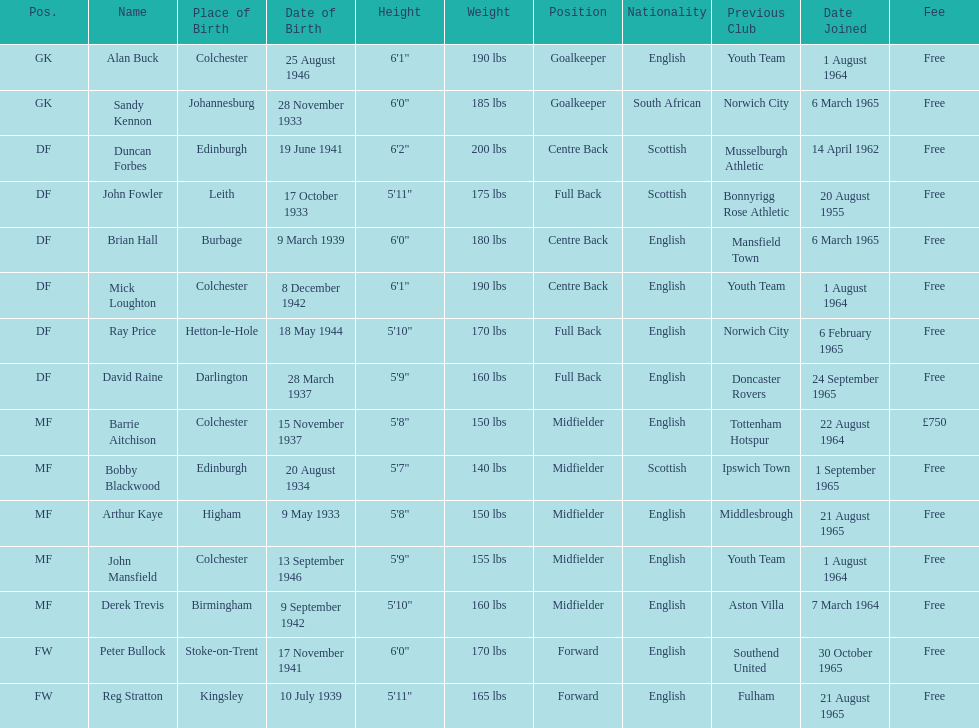I'm looking to parse the entire table for insights. Could you assist me with that? {'header': ['Pos.', 'Name', 'Place of Birth', 'Date of Birth', 'Height', 'Weight', 'Position', 'Nationality', 'Previous Club', 'Date Joined', 'Fee'], 'rows': [['GK', 'Alan Buck', 'Colchester', '25 August 1946', '6\'1"', '190 lbs', 'Goalkeeper', 'English', 'Youth Team', '1 August 1964', 'Free'], ['GK', 'Sandy Kennon', 'Johannesburg', '28 November 1933', '6\'0"', '185 lbs', 'Goalkeeper', 'South African', 'Norwich City', '6 March 1965', 'Free'], ['DF', 'Duncan Forbes', 'Edinburgh', '19 June 1941', '6\'2"', '200 lbs', 'Centre Back', 'Scottish', 'Musselburgh Athletic', '14 April 1962', 'Free'], ['DF', 'John Fowler', 'Leith', '17 October 1933', '5\'11"', '175 lbs', 'Full Back', 'Scottish', 'Bonnyrigg Rose Athletic', '20 August 1955', 'Free'], ['DF', 'Brian Hall', 'Burbage', '9 March 1939', '6\'0"', '180 lbs', 'Centre Back', 'English', 'Mansfield Town', '6 March 1965', 'Free'], ['DF', 'Mick Loughton', 'Colchester', '8 December 1942', '6\'1"', '190 lbs', 'Centre Back', 'English', 'Youth Team', '1 August 1964', 'Free'], ['DF', 'Ray Price', 'Hetton-le-Hole', '18 May 1944', '5\'10"', '170 lbs', 'Full Back', 'English', 'Norwich City', '6 February 1965', 'Free'], ['DF', 'David Raine', 'Darlington', '28 March 1937', '5\'9"', '160 lbs', 'Full Back', 'English', 'Doncaster Rovers', '24 September 1965', 'Free'], ['MF', 'Barrie Aitchison', 'Colchester', '15 November 1937', '5\'8"', '150 lbs', 'Midfielder', 'English', 'Tottenham Hotspur', '22 August 1964', '£750'], ['MF', 'Bobby Blackwood', 'Edinburgh', '20 August 1934', '5\'7"', '140 lbs', 'Midfielder', 'Scottish', 'Ipswich Town', '1 September 1965', 'Free'], ['MF', 'Arthur Kaye', 'Higham', '9 May 1933', '5\'8"', '150 lbs', 'Midfielder', 'English', 'Middlesbrough', '21 August 1965', 'Free'], ['MF', 'John Mansfield', 'Colchester', '13 September 1946', '5\'9"', '155 lbs', 'Midfielder', 'English', 'Youth Team', '1 August 1964', 'Free'], ['MF', 'Derek Trevis', 'Birmingham', '9 September 1942', '5\'10"', '160 lbs', 'Midfielder', 'English', 'Aston Villa', '7 March 1964', 'Free'], ['FW', 'Peter Bullock', 'Stoke-on-Trent', '17 November 1941', '6\'0"', '170 lbs', 'Forward', 'English', 'Southend United', '30 October 1965', 'Free'], ['FW', 'Reg Stratton', 'Kingsley', '10 July 1939', '5\'11"', '165 lbs', 'Forward', 'English', 'Fulham', '21 August 1965', 'Free']]} Name the player whose fee was not free. Barrie Aitchison. 